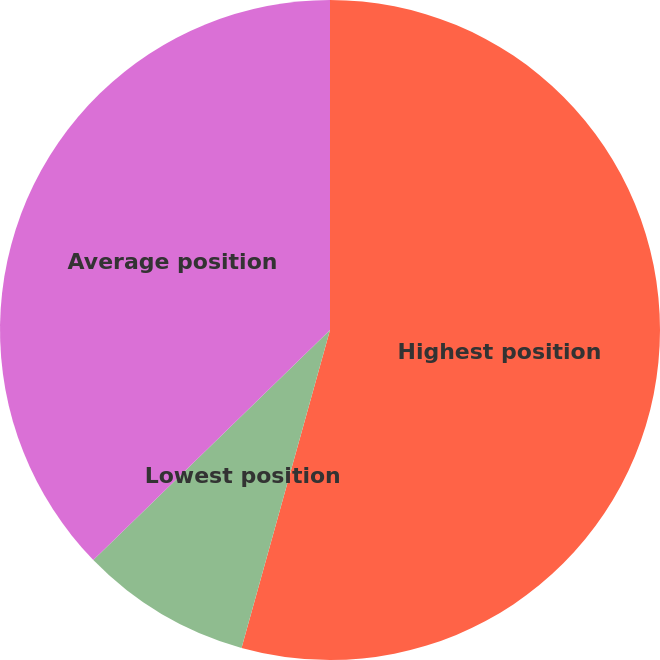<chart> <loc_0><loc_0><loc_500><loc_500><pie_chart><fcel>Highest position<fcel>Lowest position<fcel>Average position<nl><fcel>54.32%<fcel>8.41%<fcel>37.27%<nl></chart> 